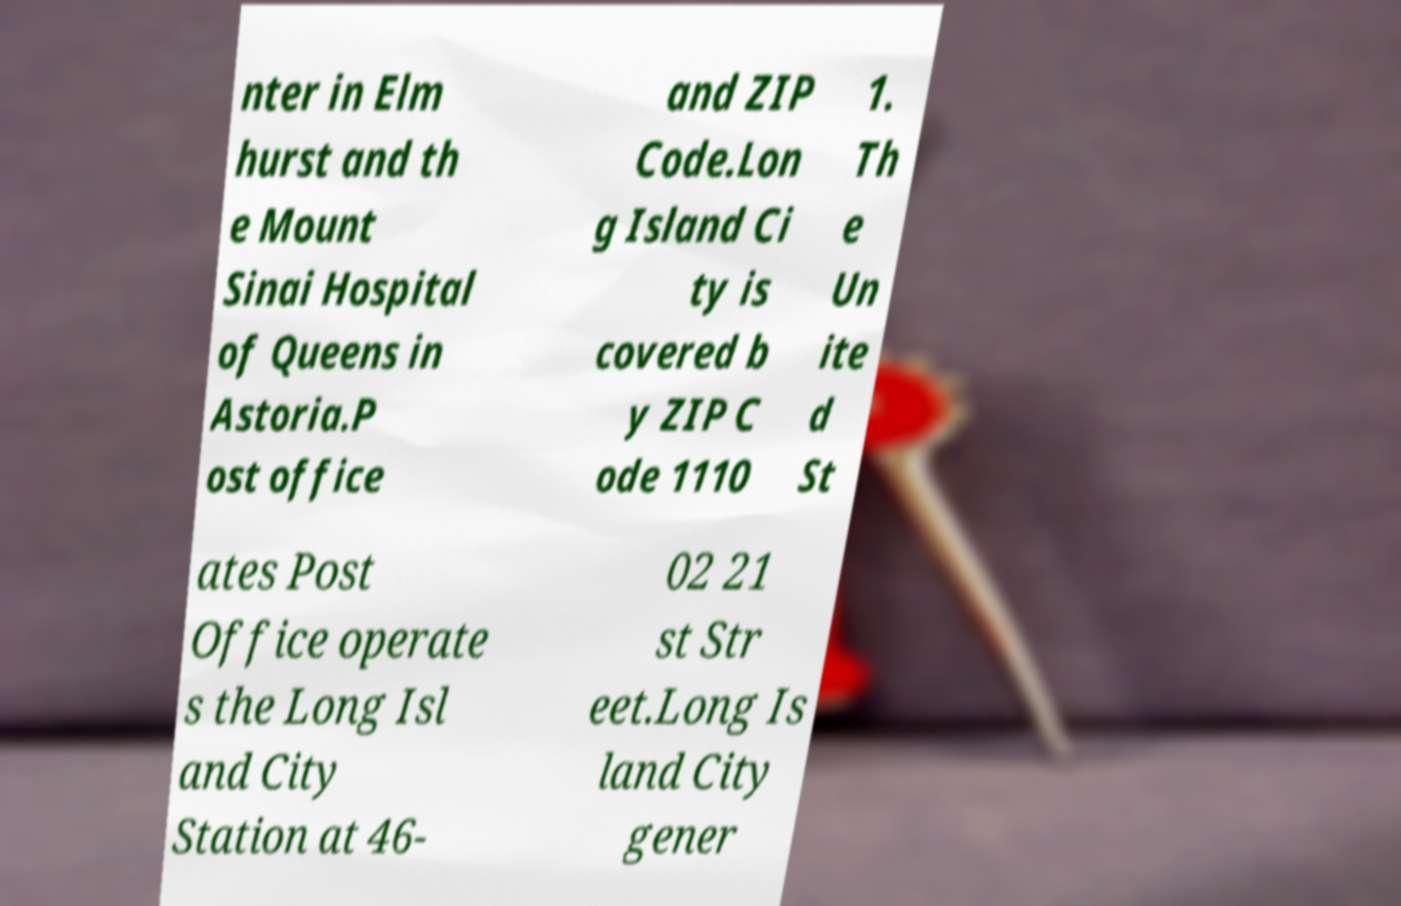Please read and relay the text visible in this image. What does it say? nter in Elm hurst and th e Mount Sinai Hospital of Queens in Astoria.P ost office and ZIP Code.Lon g Island Ci ty is covered b y ZIP C ode 1110 1. Th e Un ite d St ates Post Office operate s the Long Isl and City Station at 46- 02 21 st Str eet.Long Is land City gener 